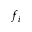Convert formula to latex. <formula><loc_0><loc_0><loc_500><loc_500>f _ { i }</formula> 